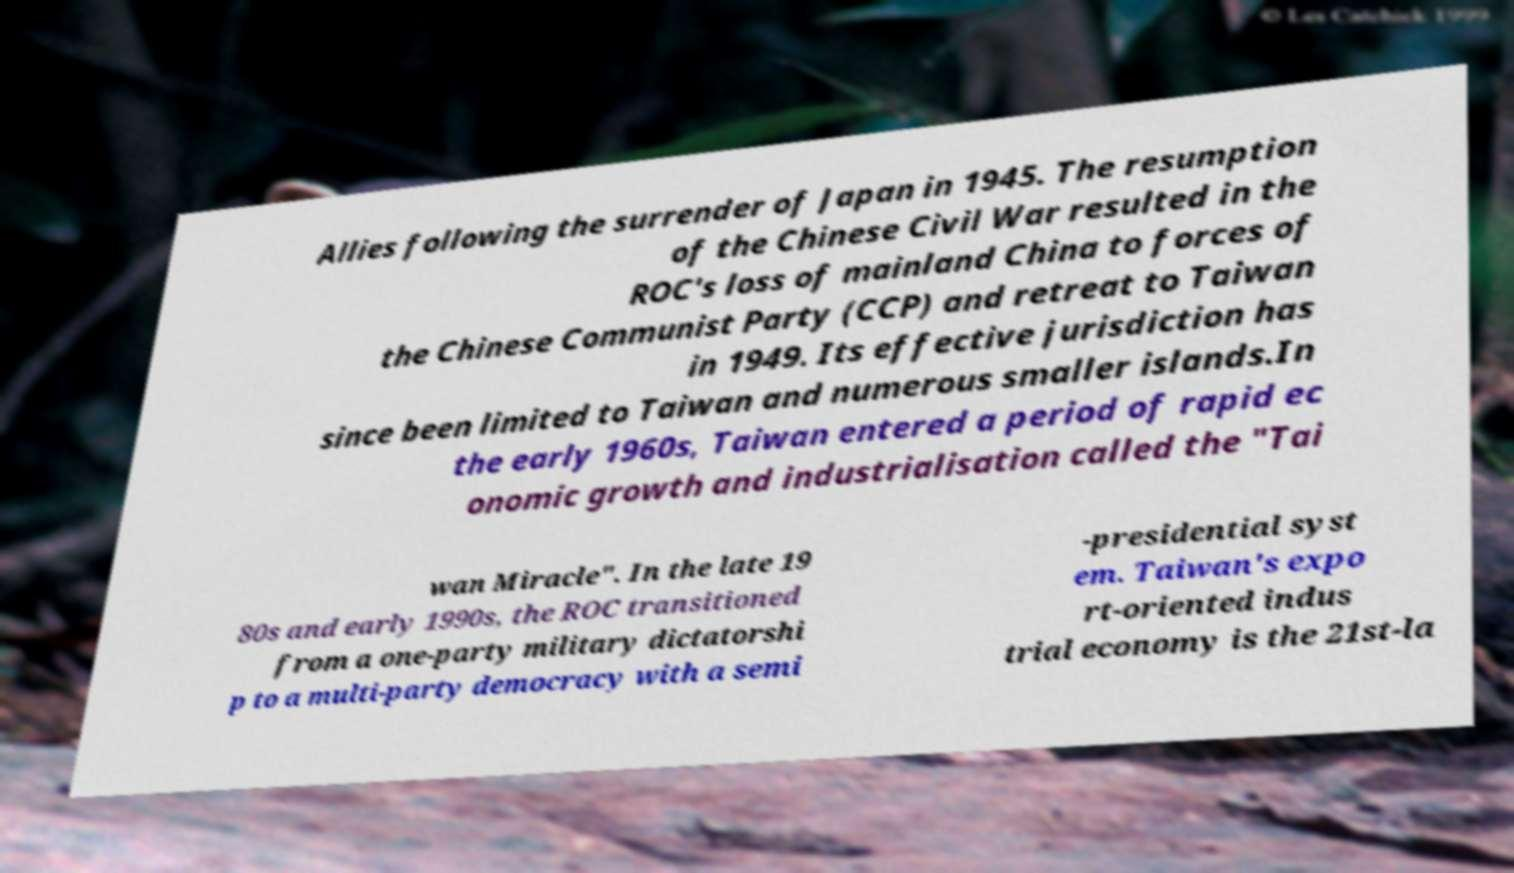Please read and relay the text visible in this image. What does it say? Allies following the surrender of Japan in 1945. The resumption of the Chinese Civil War resulted in the ROC's loss of mainland China to forces of the Chinese Communist Party (CCP) and retreat to Taiwan in 1949. Its effective jurisdiction has since been limited to Taiwan and numerous smaller islands.In the early 1960s, Taiwan entered a period of rapid ec onomic growth and industrialisation called the "Tai wan Miracle". In the late 19 80s and early 1990s, the ROC transitioned from a one-party military dictatorshi p to a multi-party democracy with a semi -presidential syst em. Taiwan's expo rt-oriented indus trial economy is the 21st-la 